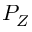<formula> <loc_0><loc_0><loc_500><loc_500>P _ { Z }</formula> 